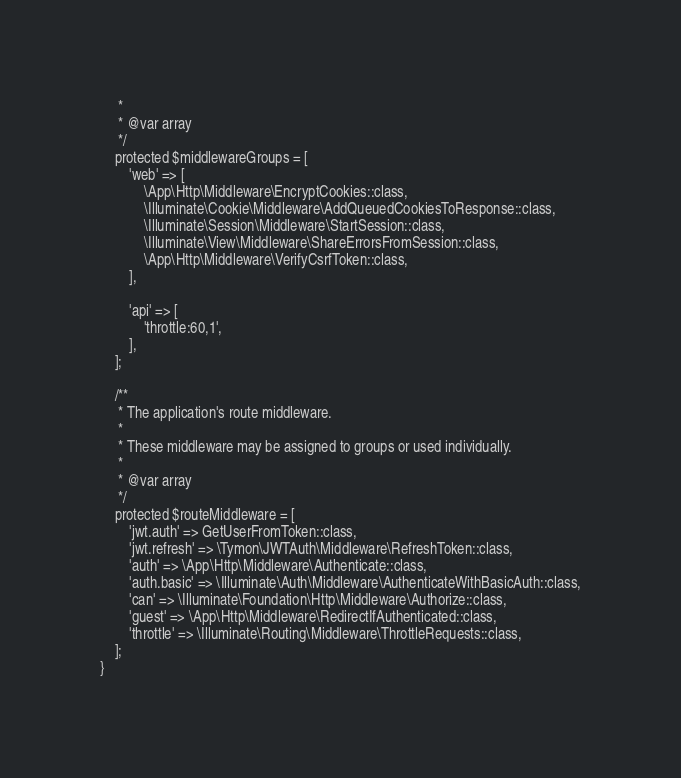<code> <loc_0><loc_0><loc_500><loc_500><_PHP_>     *
     * @var array
     */
    protected $middlewareGroups = [
        'web' => [
            \App\Http\Middleware\EncryptCookies::class,
            \Illuminate\Cookie\Middleware\AddQueuedCookiesToResponse::class,
            \Illuminate\Session\Middleware\StartSession::class,
            \Illuminate\View\Middleware\ShareErrorsFromSession::class,
            \App\Http\Middleware\VerifyCsrfToken::class,
        ],

        'api' => [
            'throttle:60,1',
        ],
    ];

    /**
     * The application's route middleware.
     *
     * These middleware may be assigned to groups or used individually.
     *
     * @var array
     */
    protected $routeMiddleware = [
        'jwt.auth' => GetUserFromToken::class,
        'jwt.refresh' => \Tymon\JWTAuth\Middleware\RefreshToken::class,
        'auth' => \App\Http\Middleware\Authenticate::class,
        'auth.basic' => \Illuminate\Auth\Middleware\AuthenticateWithBasicAuth::class,
        'can' => \Illuminate\Foundation\Http\Middleware\Authorize::class,
        'guest' => \App\Http\Middleware\RedirectIfAuthenticated::class,
        'throttle' => \Illuminate\Routing\Middleware\ThrottleRequests::class,
    ];
}
</code> 